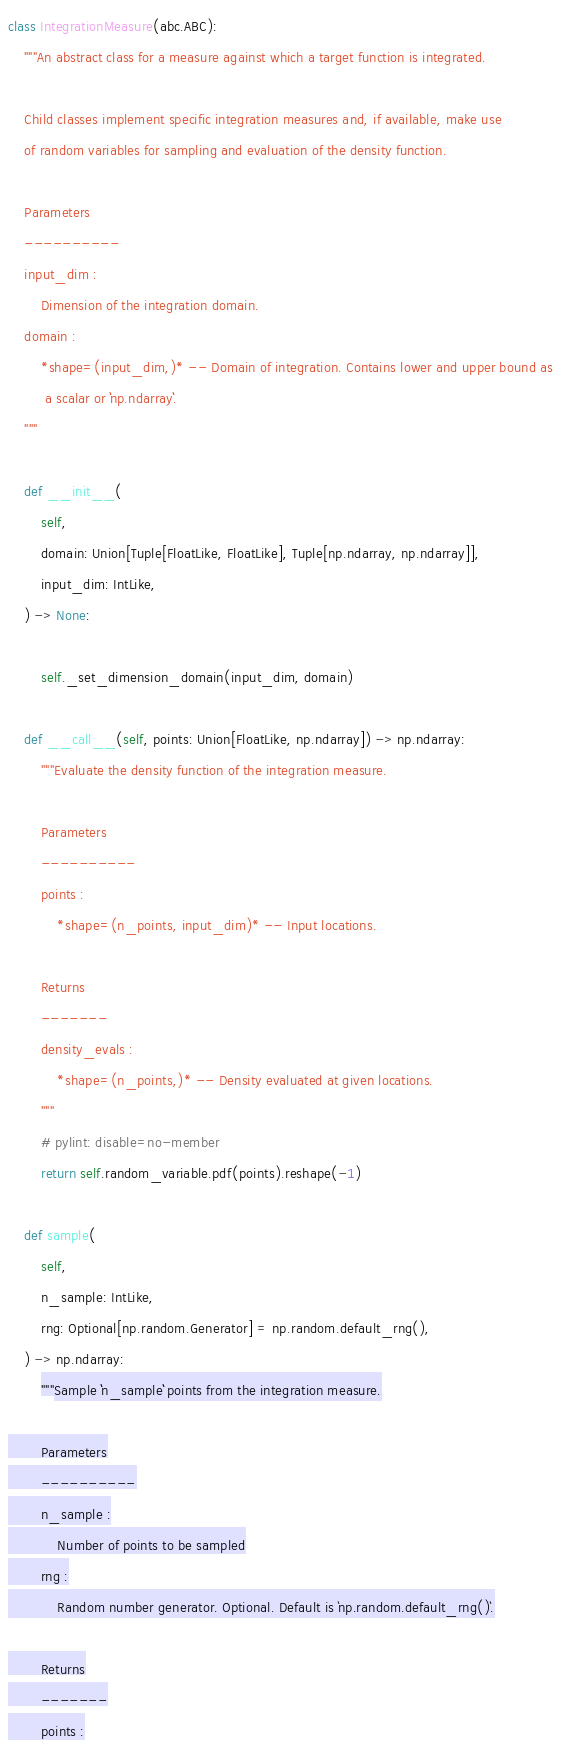<code> <loc_0><loc_0><loc_500><loc_500><_Python_>

class IntegrationMeasure(abc.ABC):
    """An abstract class for a measure against which a target function is integrated.

    Child classes implement specific integration measures and, if available, make use
    of random variables for sampling and evaluation of the density function.

    Parameters
    ----------
    input_dim :
        Dimension of the integration domain.
    domain :
        *shape=(input_dim,)* -- Domain of integration. Contains lower and upper bound as
         a scalar or ``np.ndarray``.
    """

    def __init__(
        self,
        domain: Union[Tuple[FloatLike, FloatLike], Tuple[np.ndarray, np.ndarray]],
        input_dim: IntLike,
    ) -> None:

        self._set_dimension_domain(input_dim, domain)

    def __call__(self, points: Union[FloatLike, np.ndarray]) -> np.ndarray:
        """Evaluate the density function of the integration measure.

        Parameters
        ----------
        points :
            *shape=(n_points, input_dim)* -- Input locations.

        Returns
        -------
        density_evals :
            *shape=(n_points,)* -- Density evaluated at given locations.
        """
        # pylint: disable=no-member
        return self.random_variable.pdf(points).reshape(-1)

    def sample(
        self,
        n_sample: IntLike,
        rng: Optional[np.random.Generator] = np.random.default_rng(),
    ) -> np.ndarray:
        """Sample ``n_sample`` points from the integration measure.

        Parameters
        ----------
        n_sample :
            Number of points to be sampled
        rng :
            Random number generator. Optional. Default is `np.random.default_rng()`.

        Returns
        -------
        points :</code> 